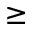Convert formula to latex. <formula><loc_0><loc_0><loc_500><loc_500>\geq</formula> 